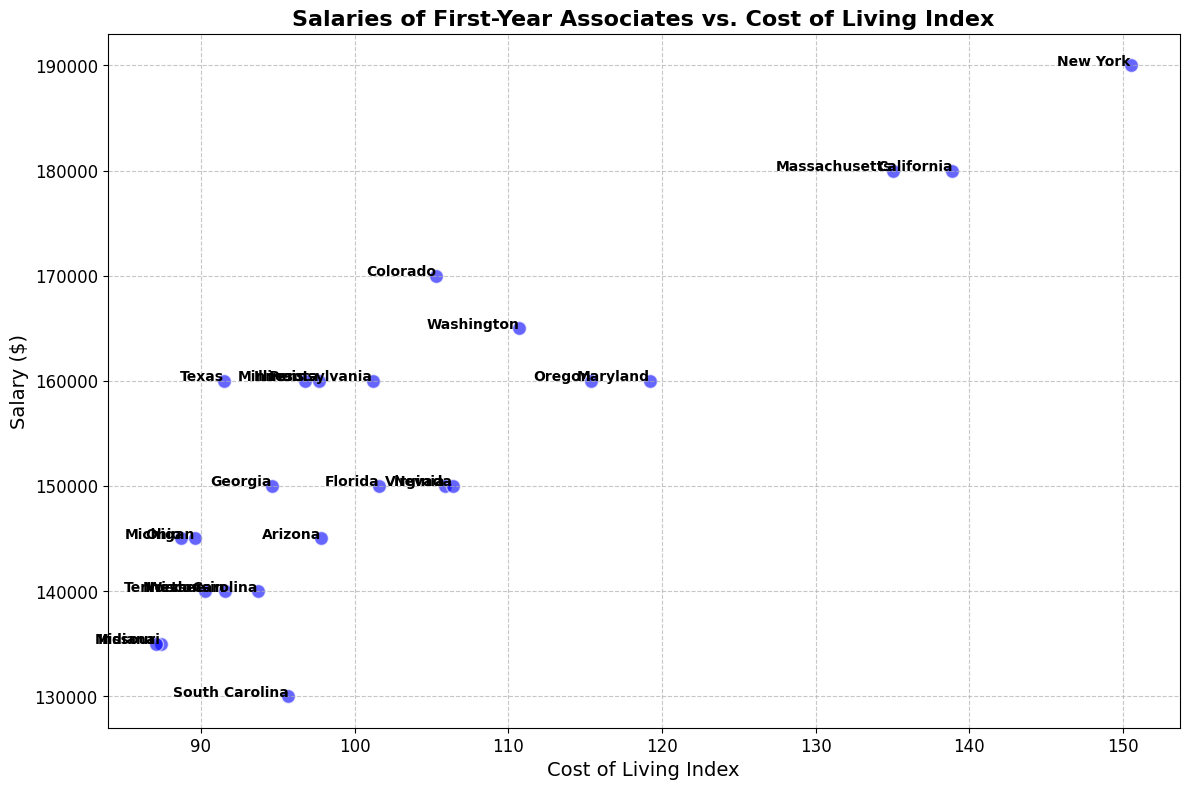What is the state with the highest salary for first-year associates? The point labeled "New York" is the highest on the y-axis, indicating the highest salary.
Answer: New York How does the Cost of Living Index in Texas compare to that in California? Locate the labels "Texas" and "California" on the x-axis. Texas has a lower Cost of Living Index (91.5) than California (138.9).
Answer: Texas has a lower cost of living than California Which states have salaries below $150,000 and Cost of Living Index below 100? Identify the points with salaries below $150,000 and index below 100. Indiana, Missouri, South Carolina, Wisconsin, Tennessee, Michigan, and Ohio meet these conditions.
Answer: Indiana, Missouri, South Carolina, Wisconsin, Tennessee, Michigan, Ohio What is the average salary of first-year associates in states with a Cost of Living Index above 130? Identify and list the salaries for states with a Cost of Living Index above 130: New York ($190,000), California ($180,000), Massachusetts ($180,000). Calculate the average: (190000 + 180000 + 180000)/3 = $183,333.33
Answer: $183,333.33 Which state has the lowest salary despite having a Cost of Living Index above 100? Identify points with a Cost of Living Index above 100 and find the lowest y-coordinate. South Carolina has the lowest salary ($130,000) despite having a Cost of Living Index of 95.7.
Answer: South Carolina 